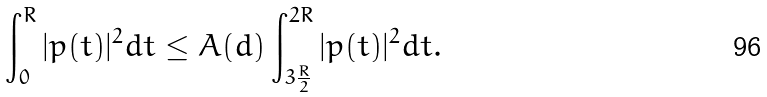<formula> <loc_0><loc_0><loc_500><loc_500>\int _ { 0 } ^ { R } | p ( t ) | ^ { 2 } d t \leq A ( d ) \int _ { 3 \frac { R } { 2 } } ^ { 2 R } | p ( t ) | ^ { 2 } d t .</formula> 